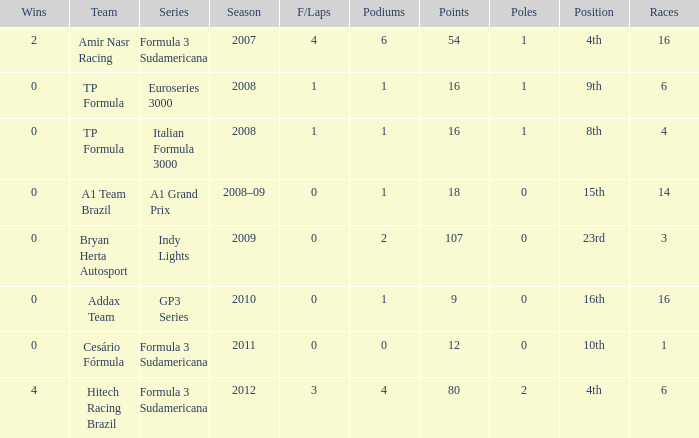What team did he compete for in the GP3 series? Addax Team. Would you mind parsing the complete table? {'header': ['Wins', 'Team', 'Series', 'Season', 'F/Laps', 'Podiums', 'Points', 'Poles', 'Position', 'Races'], 'rows': [['2', 'Amir Nasr Racing', 'Formula 3 Sudamericana', '2007', '4', '6', '54', '1', '4th', '16'], ['0', 'TP Formula', 'Euroseries 3000', '2008', '1', '1', '16', '1', '9th', '6'], ['0', 'TP Formula', 'Italian Formula 3000', '2008', '1', '1', '16', '1', '8th', '4'], ['0', 'A1 Team Brazil', 'A1 Grand Prix', '2008–09', '0', '1', '18', '0', '15th', '14'], ['0', 'Bryan Herta Autosport', 'Indy Lights', '2009', '0', '2', '107', '0', '23rd', '3'], ['0', 'Addax Team', 'GP3 Series', '2010', '0', '1', '9', '0', '16th', '16'], ['0', 'Cesário Fórmula', 'Formula 3 Sudamericana', '2011', '0', '0', '12', '0', '10th', '1'], ['4', 'Hitech Racing Brazil', 'Formula 3 Sudamericana', '2012', '3', '4', '80', '2', '4th', '6']]} 